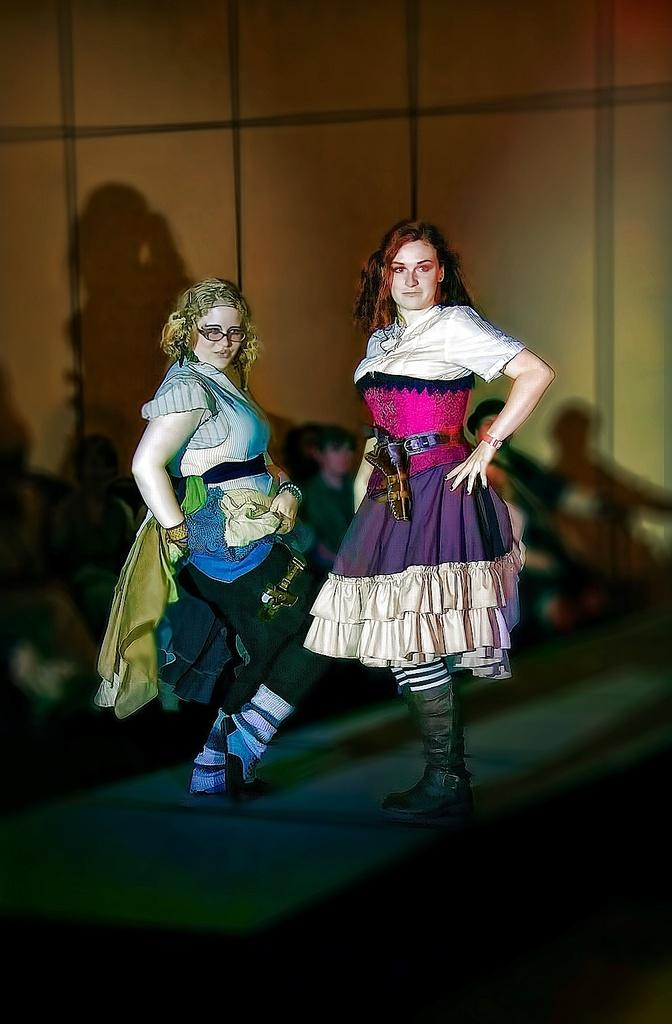How many women are on the stage in the image? There are two women standing on the stage in the image. What can be seen behind the women on the stage? There are people behind the women in the image. What is visible in the background of the image? There is a wall in the background of the image. What type of stew is being served in the room in the image? There is no room or stew present in the image; it features two women standing on a stage with people behind them and a wall in the background. 